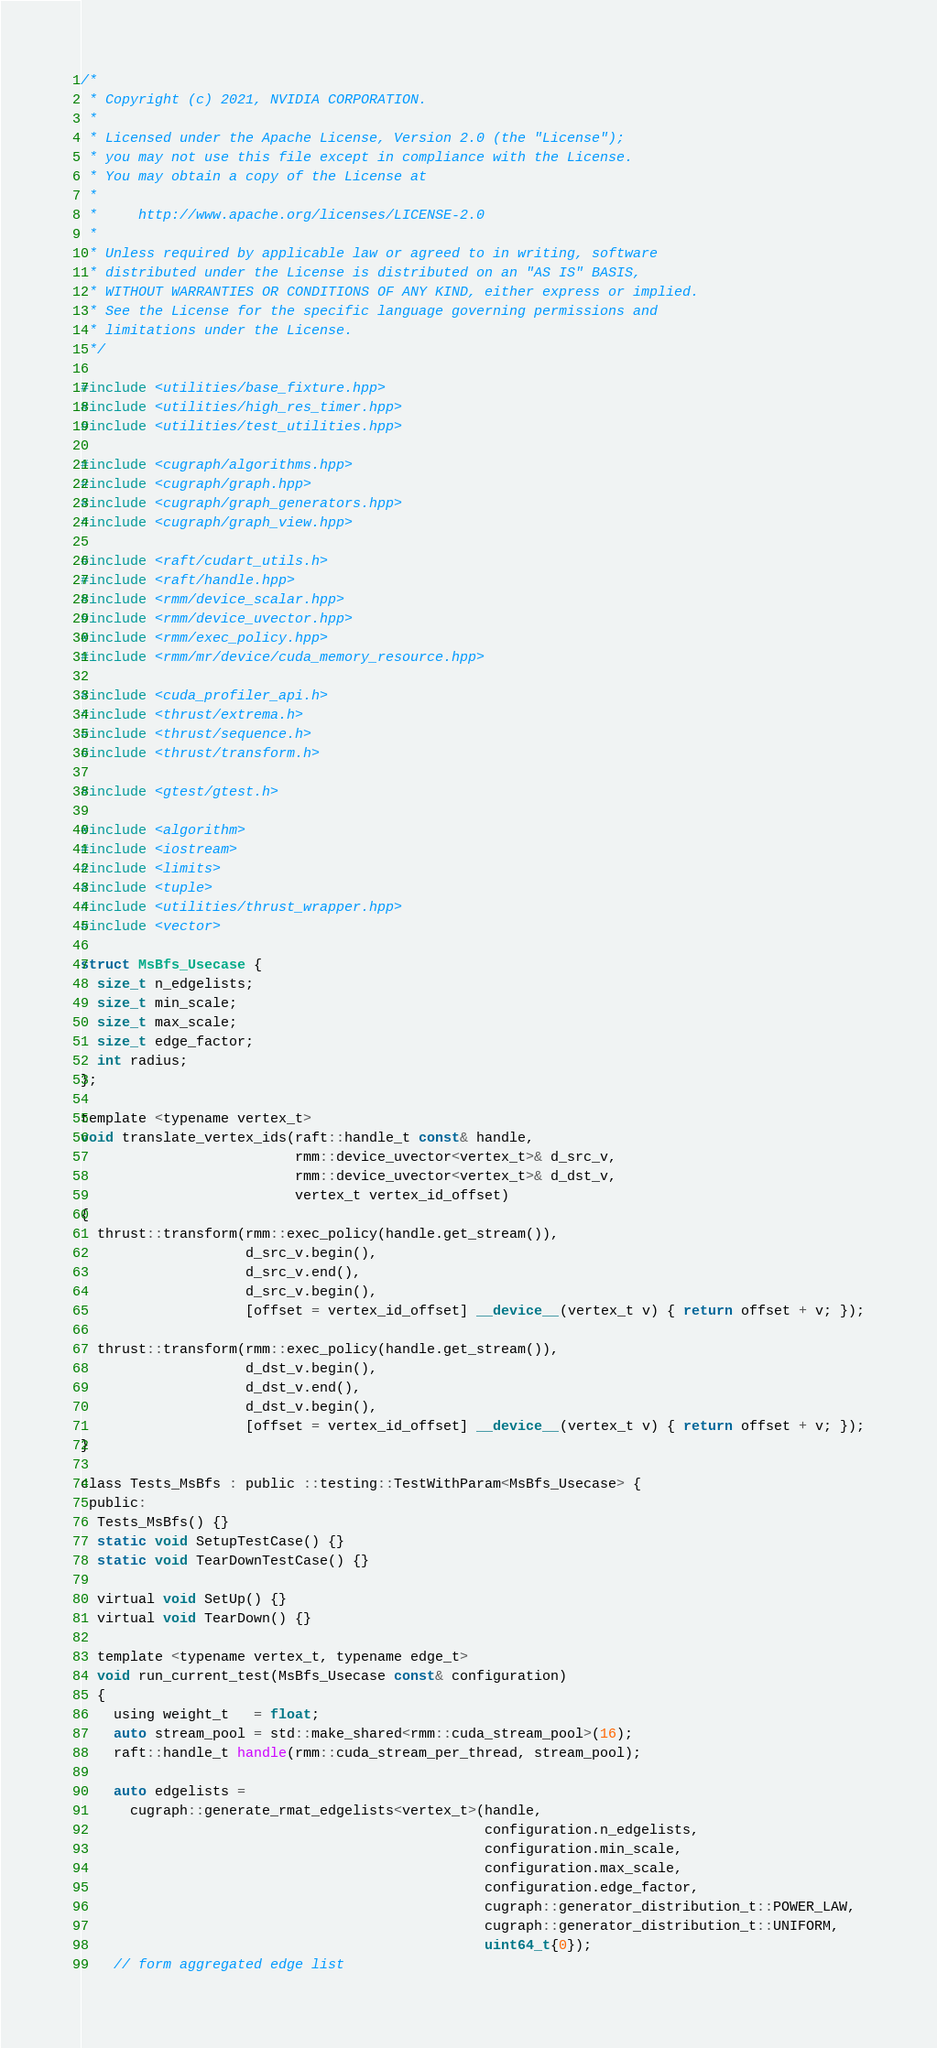<code> <loc_0><loc_0><loc_500><loc_500><_Cuda_>/*
 * Copyright (c) 2021, NVIDIA CORPORATION.
 *
 * Licensed under the Apache License, Version 2.0 (the "License");
 * you may not use this file except in compliance with the License.
 * You may obtain a copy of the License at
 *
 *     http://www.apache.org/licenses/LICENSE-2.0
 *
 * Unless required by applicable law or agreed to in writing, software
 * distributed under the License is distributed on an "AS IS" BASIS,
 * WITHOUT WARRANTIES OR CONDITIONS OF ANY KIND, either express or implied.
 * See the License for the specific language governing permissions and
 * limitations under the License.
 */

#include <utilities/base_fixture.hpp>
#include <utilities/high_res_timer.hpp>
#include <utilities/test_utilities.hpp>

#include <cugraph/algorithms.hpp>
#include <cugraph/graph.hpp>
#include <cugraph/graph_generators.hpp>
#include <cugraph/graph_view.hpp>

#include <raft/cudart_utils.h>
#include <raft/handle.hpp>
#include <rmm/device_scalar.hpp>
#include <rmm/device_uvector.hpp>
#include <rmm/exec_policy.hpp>
#include <rmm/mr/device/cuda_memory_resource.hpp>

#include <cuda_profiler_api.h>
#include <thrust/extrema.h>
#include <thrust/sequence.h>
#include <thrust/transform.h>

#include <gtest/gtest.h>

#include <algorithm>
#include <iostream>
#include <limits>
#include <tuple>
#include <utilities/thrust_wrapper.hpp>
#include <vector>

struct MsBfs_Usecase {
  size_t n_edgelists;
  size_t min_scale;
  size_t max_scale;
  size_t edge_factor;
  int radius;
};

template <typename vertex_t>
void translate_vertex_ids(raft::handle_t const& handle,
                          rmm::device_uvector<vertex_t>& d_src_v,
                          rmm::device_uvector<vertex_t>& d_dst_v,
                          vertex_t vertex_id_offset)
{
  thrust::transform(rmm::exec_policy(handle.get_stream()),
                    d_src_v.begin(),
                    d_src_v.end(),
                    d_src_v.begin(),
                    [offset = vertex_id_offset] __device__(vertex_t v) { return offset + v; });

  thrust::transform(rmm::exec_policy(handle.get_stream()),
                    d_dst_v.begin(),
                    d_dst_v.end(),
                    d_dst_v.begin(),
                    [offset = vertex_id_offset] __device__(vertex_t v) { return offset + v; });
}

class Tests_MsBfs : public ::testing::TestWithParam<MsBfs_Usecase> {
 public:
  Tests_MsBfs() {}
  static void SetupTestCase() {}
  static void TearDownTestCase() {}

  virtual void SetUp() {}
  virtual void TearDown() {}

  template <typename vertex_t, typename edge_t>
  void run_current_test(MsBfs_Usecase const& configuration)
  {
    using weight_t   = float;
    auto stream_pool = std::make_shared<rmm::cuda_stream_pool>(16);
    raft::handle_t handle(rmm::cuda_stream_per_thread, stream_pool);

    auto edgelists =
      cugraph::generate_rmat_edgelists<vertex_t>(handle,
                                                 configuration.n_edgelists,
                                                 configuration.min_scale,
                                                 configuration.max_scale,
                                                 configuration.edge_factor,
                                                 cugraph::generator_distribution_t::POWER_LAW,
                                                 cugraph::generator_distribution_t::UNIFORM,
                                                 uint64_t{0});
    // form aggregated edge list</code> 